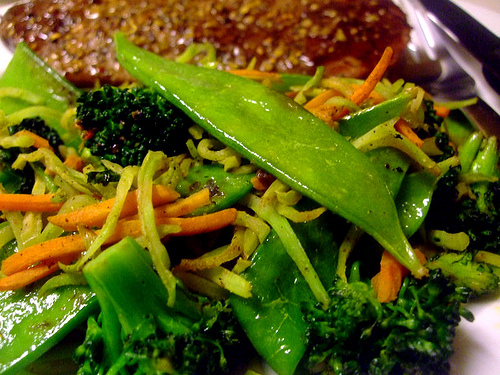<image>What type of meat is behind the veggies? I don't know the type of meat behind the veggies. It could be steak, beef, pork, or chicken. How does it taste? I'm not sure how it tastes, it could taste sweet, yummy, good, savory or spicy. What is the dressing of the salad? I am not sure about the dressing of the salad. It could be 'oil', 'asian', 'vinaigrette' or 'italian'. What type of meat is behind the veggies? I don't know the type of meat that is behind the veggies. It can be steak, beef, pork or chicken. How does it taste? I don't know how it tastes. It can be sweet, yummy, good or savory. What is the dressing of the salad? The dressing of the salad can be seen as 'oil', 'asian', 'vinaigrette', or 'italian'. 